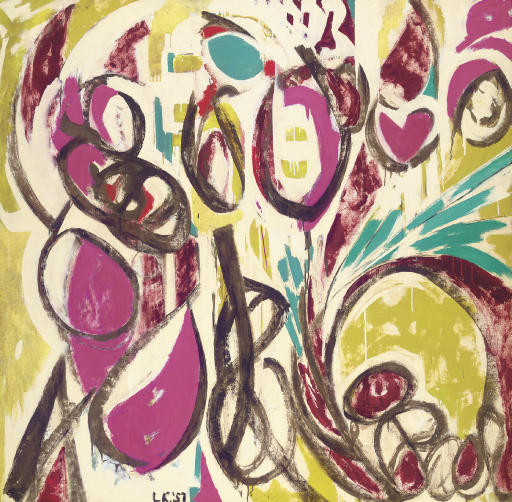Can you describe the influence of graffiti art on this painting? Certainly! The influence of graffiti is evident in the painting through its bold strokes and abstract forms that resemble street art's raw and expressive nature. The canvas adopts techniques similar to spray painting and tagging, commonly seen in urban graffiti. This style incorporates elements of rebellion and personal expression, characteristics central to graffiti culture, to create art that is both impactful and visually engaging. How does the color choice contribute to the graffiti feel? The vibrant use of colors, particularly the neon-like yellow and electrifying pink, are reminiscent of the vivid palettes often found in graffiti. These colors make the artwork pop and stand out, akin to how graffiti draws attention in public spaces. Additionally, the unexpected color contrasts and combinations enhance the visual impact, mimicking the daring and unconventional choices typical in street art. 